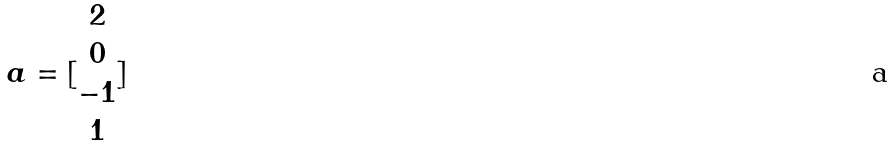<formula> <loc_0><loc_0><loc_500><loc_500>a = [ \begin{matrix} 2 \\ 0 \\ - 1 \\ 1 \end{matrix} ]</formula> 